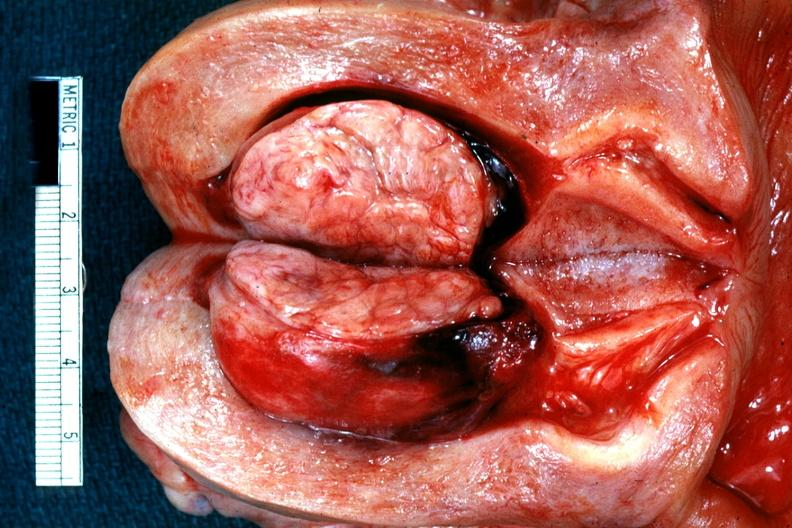does this image show excellent example of submucous myoma?
Answer the question using a single word or phrase. Yes 